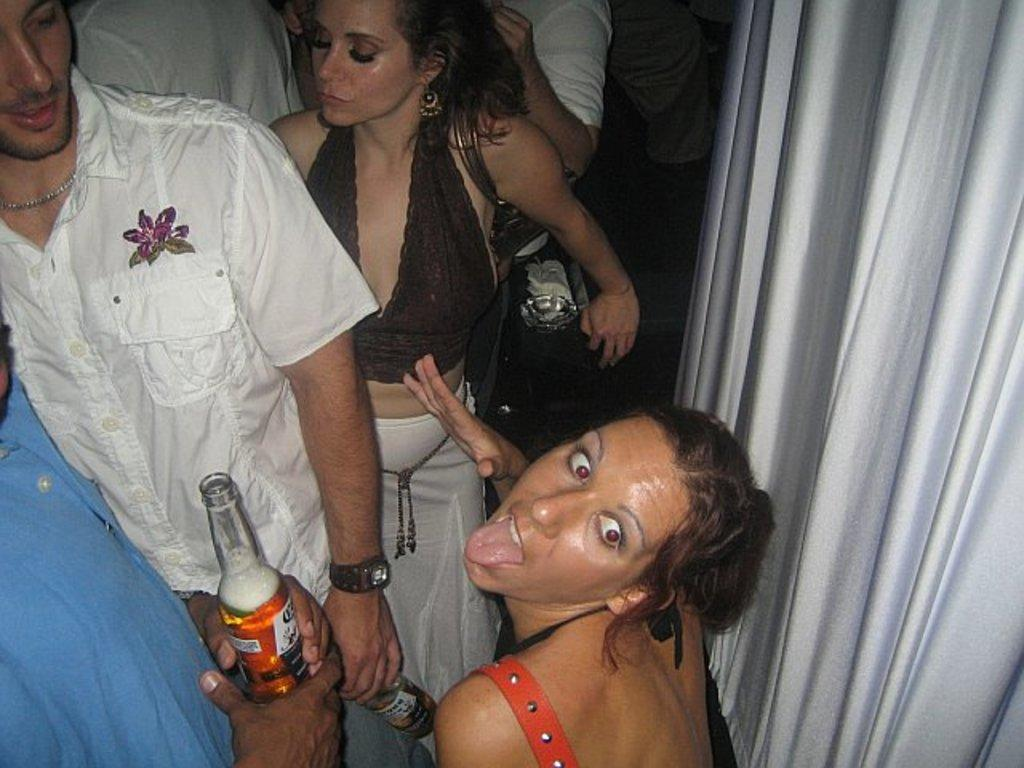What is happening in the image? There are persons standing in the image. Can you describe what the persons are doing with a specific object? Two persons are holding a bottle in the image. What is one person wearing that is not clothing? One person is wearing a bag in the image. What type of love can be seen between the two persons holding the bottle in the image? There is no indication of love or any emotional connection between the persons holding the bottle in the image. 